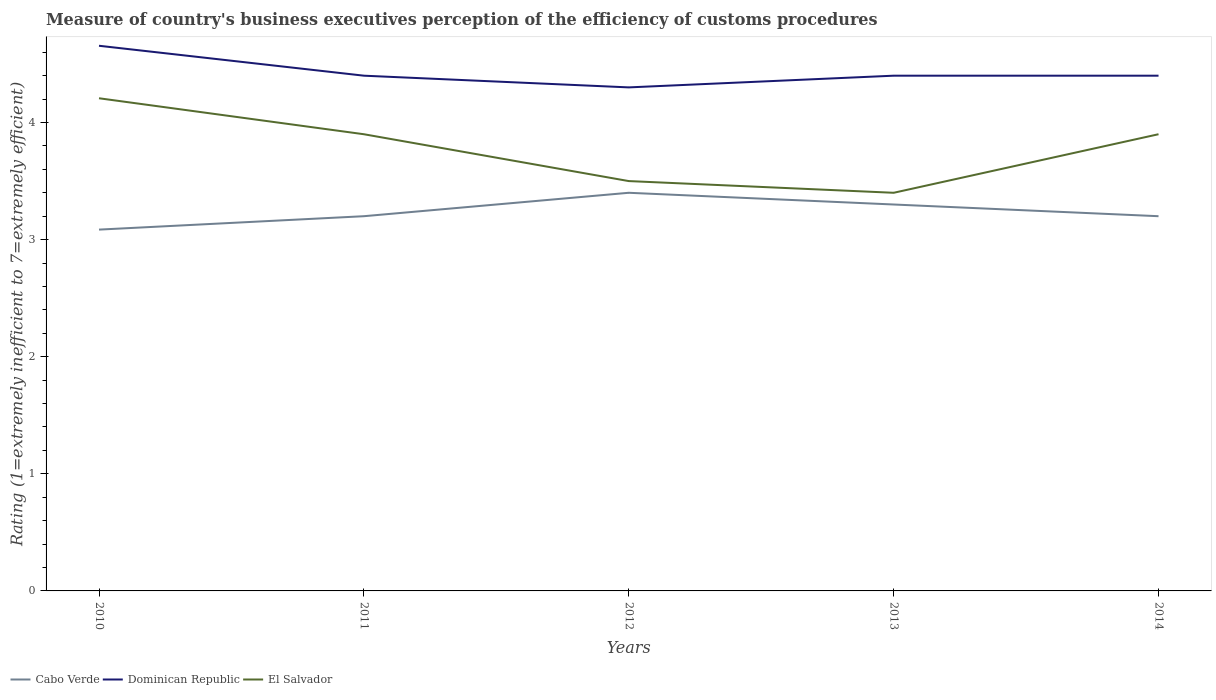Across all years, what is the maximum rating of the efficiency of customs procedure in Cabo Verde?
Ensure brevity in your answer.  3.09. What is the total rating of the efficiency of customs procedure in El Salvador in the graph?
Offer a very short reply. 0.81. What is the difference between the highest and the second highest rating of the efficiency of customs procedure in Cabo Verde?
Offer a very short reply. 0.31. What is the difference between the highest and the lowest rating of the efficiency of customs procedure in El Salvador?
Ensure brevity in your answer.  3. Is the rating of the efficiency of customs procedure in El Salvador strictly greater than the rating of the efficiency of customs procedure in Cabo Verde over the years?
Your answer should be very brief. No. How many years are there in the graph?
Keep it short and to the point. 5. Are the values on the major ticks of Y-axis written in scientific E-notation?
Provide a short and direct response. No. How many legend labels are there?
Your response must be concise. 3. What is the title of the graph?
Give a very brief answer. Measure of country's business executives perception of the efficiency of customs procedures. Does "Algeria" appear as one of the legend labels in the graph?
Your answer should be compact. No. What is the label or title of the X-axis?
Give a very brief answer. Years. What is the label or title of the Y-axis?
Offer a very short reply. Rating (1=extremely inefficient to 7=extremely efficient). What is the Rating (1=extremely inefficient to 7=extremely efficient) of Cabo Verde in 2010?
Your answer should be very brief. 3.09. What is the Rating (1=extremely inefficient to 7=extremely efficient) in Dominican Republic in 2010?
Offer a terse response. 4.66. What is the Rating (1=extremely inefficient to 7=extremely efficient) in El Salvador in 2010?
Your response must be concise. 4.21. What is the Rating (1=extremely inefficient to 7=extremely efficient) in Cabo Verde in 2011?
Your answer should be compact. 3.2. What is the Rating (1=extremely inefficient to 7=extremely efficient) of Dominican Republic in 2011?
Offer a very short reply. 4.4. What is the Rating (1=extremely inefficient to 7=extremely efficient) of El Salvador in 2011?
Keep it short and to the point. 3.9. What is the Rating (1=extremely inefficient to 7=extremely efficient) of Dominican Republic in 2012?
Provide a succinct answer. 4.3. What is the Rating (1=extremely inefficient to 7=extremely efficient) in El Salvador in 2012?
Your answer should be compact. 3.5. What is the Rating (1=extremely inefficient to 7=extremely efficient) of Dominican Republic in 2013?
Ensure brevity in your answer.  4.4. What is the Rating (1=extremely inefficient to 7=extremely efficient) of El Salvador in 2013?
Make the answer very short. 3.4. What is the Rating (1=extremely inefficient to 7=extremely efficient) in El Salvador in 2014?
Provide a succinct answer. 3.9. Across all years, what is the maximum Rating (1=extremely inefficient to 7=extremely efficient) in Cabo Verde?
Ensure brevity in your answer.  3.4. Across all years, what is the maximum Rating (1=extremely inefficient to 7=extremely efficient) of Dominican Republic?
Give a very brief answer. 4.66. Across all years, what is the maximum Rating (1=extremely inefficient to 7=extremely efficient) of El Salvador?
Offer a very short reply. 4.21. Across all years, what is the minimum Rating (1=extremely inefficient to 7=extremely efficient) of Cabo Verde?
Keep it short and to the point. 3.09. What is the total Rating (1=extremely inefficient to 7=extremely efficient) of Cabo Verde in the graph?
Your answer should be compact. 16.19. What is the total Rating (1=extremely inefficient to 7=extremely efficient) of Dominican Republic in the graph?
Provide a succinct answer. 22.16. What is the total Rating (1=extremely inefficient to 7=extremely efficient) of El Salvador in the graph?
Keep it short and to the point. 18.91. What is the difference between the Rating (1=extremely inefficient to 7=extremely efficient) in Cabo Verde in 2010 and that in 2011?
Ensure brevity in your answer.  -0.11. What is the difference between the Rating (1=extremely inefficient to 7=extremely efficient) in Dominican Republic in 2010 and that in 2011?
Your answer should be very brief. 0.26. What is the difference between the Rating (1=extremely inefficient to 7=extremely efficient) of El Salvador in 2010 and that in 2011?
Your answer should be very brief. 0.31. What is the difference between the Rating (1=extremely inefficient to 7=extremely efficient) of Cabo Verde in 2010 and that in 2012?
Make the answer very short. -0.31. What is the difference between the Rating (1=extremely inefficient to 7=extremely efficient) in Dominican Republic in 2010 and that in 2012?
Your answer should be very brief. 0.36. What is the difference between the Rating (1=extremely inefficient to 7=extremely efficient) in El Salvador in 2010 and that in 2012?
Make the answer very short. 0.71. What is the difference between the Rating (1=extremely inefficient to 7=extremely efficient) of Cabo Verde in 2010 and that in 2013?
Give a very brief answer. -0.21. What is the difference between the Rating (1=extremely inefficient to 7=extremely efficient) of Dominican Republic in 2010 and that in 2013?
Your answer should be very brief. 0.26. What is the difference between the Rating (1=extremely inefficient to 7=extremely efficient) in El Salvador in 2010 and that in 2013?
Give a very brief answer. 0.81. What is the difference between the Rating (1=extremely inefficient to 7=extremely efficient) of Cabo Verde in 2010 and that in 2014?
Give a very brief answer. -0.11. What is the difference between the Rating (1=extremely inefficient to 7=extremely efficient) in Dominican Republic in 2010 and that in 2014?
Keep it short and to the point. 0.26. What is the difference between the Rating (1=extremely inefficient to 7=extremely efficient) of El Salvador in 2010 and that in 2014?
Your answer should be very brief. 0.31. What is the difference between the Rating (1=extremely inefficient to 7=extremely efficient) in Cabo Verde in 2011 and that in 2012?
Provide a short and direct response. -0.2. What is the difference between the Rating (1=extremely inefficient to 7=extremely efficient) of El Salvador in 2011 and that in 2013?
Offer a terse response. 0.5. What is the difference between the Rating (1=extremely inefficient to 7=extremely efficient) in Cabo Verde in 2011 and that in 2014?
Offer a very short reply. 0. What is the difference between the Rating (1=extremely inefficient to 7=extremely efficient) in El Salvador in 2012 and that in 2013?
Your response must be concise. 0.1. What is the difference between the Rating (1=extremely inefficient to 7=extremely efficient) in Cabo Verde in 2012 and that in 2014?
Your response must be concise. 0.2. What is the difference between the Rating (1=extremely inefficient to 7=extremely efficient) in El Salvador in 2012 and that in 2014?
Give a very brief answer. -0.4. What is the difference between the Rating (1=extremely inefficient to 7=extremely efficient) in Dominican Republic in 2013 and that in 2014?
Make the answer very short. 0. What is the difference between the Rating (1=extremely inefficient to 7=extremely efficient) in Cabo Verde in 2010 and the Rating (1=extremely inefficient to 7=extremely efficient) in Dominican Republic in 2011?
Keep it short and to the point. -1.31. What is the difference between the Rating (1=extremely inefficient to 7=extremely efficient) of Cabo Verde in 2010 and the Rating (1=extremely inefficient to 7=extremely efficient) of El Salvador in 2011?
Provide a short and direct response. -0.81. What is the difference between the Rating (1=extremely inefficient to 7=extremely efficient) in Dominican Republic in 2010 and the Rating (1=extremely inefficient to 7=extremely efficient) in El Salvador in 2011?
Make the answer very short. 0.76. What is the difference between the Rating (1=extremely inefficient to 7=extremely efficient) of Cabo Verde in 2010 and the Rating (1=extremely inefficient to 7=extremely efficient) of Dominican Republic in 2012?
Your response must be concise. -1.21. What is the difference between the Rating (1=extremely inefficient to 7=extremely efficient) in Cabo Verde in 2010 and the Rating (1=extremely inefficient to 7=extremely efficient) in El Salvador in 2012?
Your answer should be very brief. -0.41. What is the difference between the Rating (1=extremely inefficient to 7=extremely efficient) of Dominican Republic in 2010 and the Rating (1=extremely inefficient to 7=extremely efficient) of El Salvador in 2012?
Offer a terse response. 1.16. What is the difference between the Rating (1=extremely inefficient to 7=extremely efficient) in Cabo Verde in 2010 and the Rating (1=extremely inefficient to 7=extremely efficient) in Dominican Republic in 2013?
Offer a very short reply. -1.31. What is the difference between the Rating (1=extremely inefficient to 7=extremely efficient) of Cabo Verde in 2010 and the Rating (1=extremely inefficient to 7=extremely efficient) of El Salvador in 2013?
Provide a short and direct response. -0.31. What is the difference between the Rating (1=extremely inefficient to 7=extremely efficient) in Dominican Republic in 2010 and the Rating (1=extremely inefficient to 7=extremely efficient) in El Salvador in 2013?
Your answer should be very brief. 1.26. What is the difference between the Rating (1=extremely inefficient to 7=extremely efficient) of Cabo Verde in 2010 and the Rating (1=extremely inefficient to 7=extremely efficient) of Dominican Republic in 2014?
Provide a succinct answer. -1.31. What is the difference between the Rating (1=extremely inefficient to 7=extremely efficient) in Cabo Verde in 2010 and the Rating (1=extremely inefficient to 7=extremely efficient) in El Salvador in 2014?
Offer a terse response. -0.81. What is the difference between the Rating (1=extremely inefficient to 7=extremely efficient) in Dominican Republic in 2010 and the Rating (1=extremely inefficient to 7=extremely efficient) in El Salvador in 2014?
Offer a terse response. 0.76. What is the difference between the Rating (1=extremely inefficient to 7=extremely efficient) of Dominican Republic in 2011 and the Rating (1=extremely inefficient to 7=extremely efficient) of El Salvador in 2013?
Keep it short and to the point. 1. What is the difference between the Rating (1=extremely inefficient to 7=extremely efficient) in Cabo Verde in 2012 and the Rating (1=extremely inefficient to 7=extremely efficient) in El Salvador in 2013?
Provide a short and direct response. 0. What is the difference between the Rating (1=extremely inefficient to 7=extremely efficient) in Dominican Republic in 2012 and the Rating (1=extremely inefficient to 7=extremely efficient) in El Salvador in 2014?
Your response must be concise. 0.4. What is the average Rating (1=extremely inefficient to 7=extremely efficient) of Cabo Verde per year?
Your answer should be very brief. 3.24. What is the average Rating (1=extremely inefficient to 7=extremely efficient) in Dominican Republic per year?
Provide a succinct answer. 4.43. What is the average Rating (1=extremely inefficient to 7=extremely efficient) of El Salvador per year?
Offer a terse response. 3.78. In the year 2010, what is the difference between the Rating (1=extremely inefficient to 7=extremely efficient) of Cabo Verde and Rating (1=extremely inefficient to 7=extremely efficient) of Dominican Republic?
Your answer should be compact. -1.57. In the year 2010, what is the difference between the Rating (1=extremely inefficient to 7=extremely efficient) of Cabo Verde and Rating (1=extremely inefficient to 7=extremely efficient) of El Salvador?
Offer a very short reply. -1.12. In the year 2010, what is the difference between the Rating (1=extremely inefficient to 7=extremely efficient) of Dominican Republic and Rating (1=extremely inefficient to 7=extremely efficient) of El Salvador?
Offer a terse response. 0.45. In the year 2012, what is the difference between the Rating (1=extremely inefficient to 7=extremely efficient) in Cabo Verde and Rating (1=extremely inefficient to 7=extremely efficient) in El Salvador?
Ensure brevity in your answer.  -0.1. In the year 2013, what is the difference between the Rating (1=extremely inefficient to 7=extremely efficient) of Cabo Verde and Rating (1=extremely inefficient to 7=extremely efficient) of El Salvador?
Keep it short and to the point. -0.1. In the year 2013, what is the difference between the Rating (1=extremely inefficient to 7=extremely efficient) in Dominican Republic and Rating (1=extremely inefficient to 7=extremely efficient) in El Salvador?
Provide a short and direct response. 1. In the year 2014, what is the difference between the Rating (1=extremely inefficient to 7=extremely efficient) in Cabo Verde and Rating (1=extremely inefficient to 7=extremely efficient) in Dominican Republic?
Provide a short and direct response. -1.2. In the year 2014, what is the difference between the Rating (1=extremely inefficient to 7=extremely efficient) of Cabo Verde and Rating (1=extremely inefficient to 7=extremely efficient) of El Salvador?
Your answer should be compact. -0.7. In the year 2014, what is the difference between the Rating (1=extremely inefficient to 7=extremely efficient) of Dominican Republic and Rating (1=extremely inefficient to 7=extremely efficient) of El Salvador?
Your answer should be very brief. 0.5. What is the ratio of the Rating (1=extremely inefficient to 7=extremely efficient) in Cabo Verde in 2010 to that in 2011?
Your answer should be compact. 0.96. What is the ratio of the Rating (1=extremely inefficient to 7=extremely efficient) of Dominican Republic in 2010 to that in 2011?
Your answer should be very brief. 1.06. What is the ratio of the Rating (1=extremely inefficient to 7=extremely efficient) in El Salvador in 2010 to that in 2011?
Give a very brief answer. 1.08. What is the ratio of the Rating (1=extremely inefficient to 7=extremely efficient) of Cabo Verde in 2010 to that in 2012?
Provide a short and direct response. 0.91. What is the ratio of the Rating (1=extremely inefficient to 7=extremely efficient) in Dominican Republic in 2010 to that in 2012?
Ensure brevity in your answer.  1.08. What is the ratio of the Rating (1=extremely inefficient to 7=extremely efficient) in El Salvador in 2010 to that in 2012?
Your answer should be very brief. 1.2. What is the ratio of the Rating (1=extremely inefficient to 7=extremely efficient) in Cabo Verde in 2010 to that in 2013?
Provide a short and direct response. 0.94. What is the ratio of the Rating (1=extremely inefficient to 7=extremely efficient) of Dominican Republic in 2010 to that in 2013?
Your answer should be very brief. 1.06. What is the ratio of the Rating (1=extremely inefficient to 7=extremely efficient) in El Salvador in 2010 to that in 2013?
Your answer should be very brief. 1.24. What is the ratio of the Rating (1=extremely inefficient to 7=extremely efficient) in Cabo Verde in 2010 to that in 2014?
Offer a very short reply. 0.96. What is the ratio of the Rating (1=extremely inefficient to 7=extremely efficient) of Dominican Republic in 2010 to that in 2014?
Make the answer very short. 1.06. What is the ratio of the Rating (1=extremely inefficient to 7=extremely efficient) of El Salvador in 2010 to that in 2014?
Give a very brief answer. 1.08. What is the ratio of the Rating (1=extremely inefficient to 7=extremely efficient) in Cabo Verde in 2011 to that in 2012?
Offer a terse response. 0.94. What is the ratio of the Rating (1=extremely inefficient to 7=extremely efficient) in Dominican Republic in 2011 to that in 2012?
Provide a short and direct response. 1.02. What is the ratio of the Rating (1=extremely inefficient to 7=extremely efficient) in El Salvador in 2011 to that in 2012?
Offer a terse response. 1.11. What is the ratio of the Rating (1=extremely inefficient to 7=extremely efficient) in Cabo Verde in 2011 to that in 2013?
Your response must be concise. 0.97. What is the ratio of the Rating (1=extremely inefficient to 7=extremely efficient) of El Salvador in 2011 to that in 2013?
Your answer should be compact. 1.15. What is the ratio of the Rating (1=extremely inefficient to 7=extremely efficient) of El Salvador in 2011 to that in 2014?
Make the answer very short. 1. What is the ratio of the Rating (1=extremely inefficient to 7=extremely efficient) of Cabo Verde in 2012 to that in 2013?
Keep it short and to the point. 1.03. What is the ratio of the Rating (1=extremely inefficient to 7=extremely efficient) in Dominican Republic in 2012 to that in 2013?
Your response must be concise. 0.98. What is the ratio of the Rating (1=extremely inefficient to 7=extremely efficient) in El Salvador in 2012 to that in 2013?
Provide a short and direct response. 1.03. What is the ratio of the Rating (1=extremely inefficient to 7=extremely efficient) of Dominican Republic in 2012 to that in 2014?
Offer a terse response. 0.98. What is the ratio of the Rating (1=extremely inefficient to 7=extremely efficient) of El Salvador in 2012 to that in 2014?
Provide a succinct answer. 0.9. What is the ratio of the Rating (1=extremely inefficient to 7=extremely efficient) of Cabo Verde in 2013 to that in 2014?
Offer a very short reply. 1.03. What is the ratio of the Rating (1=extremely inefficient to 7=extremely efficient) of Dominican Republic in 2013 to that in 2014?
Make the answer very short. 1. What is the ratio of the Rating (1=extremely inefficient to 7=extremely efficient) in El Salvador in 2013 to that in 2014?
Your response must be concise. 0.87. What is the difference between the highest and the second highest Rating (1=extremely inefficient to 7=extremely efficient) in Cabo Verde?
Offer a terse response. 0.1. What is the difference between the highest and the second highest Rating (1=extremely inefficient to 7=extremely efficient) of Dominican Republic?
Your answer should be very brief. 0.26. What is the difference between the highest and the second highest Rating (1=extremely inefficient to 7=extremely efficient) of El Salvador?
Ensure brevity in your answer.  0.31. What is the difference between the highest and the lowest Rating (1=extremely inefficient to 7=extremely efficient) of Cabo Verde?
Offer a terse response. 0.31. What is the difference between the highest and the lowest Rating (1=extremely inefficient to 7=extremely efficient) in Dominican Republic?
Keep it short and to the point. 0.36. What is the difference between the highest and the lowest Rating (1=extremely inefficient to 7=extremely efficient) of El Salvador?
Offer a very short reply. 0.81. 